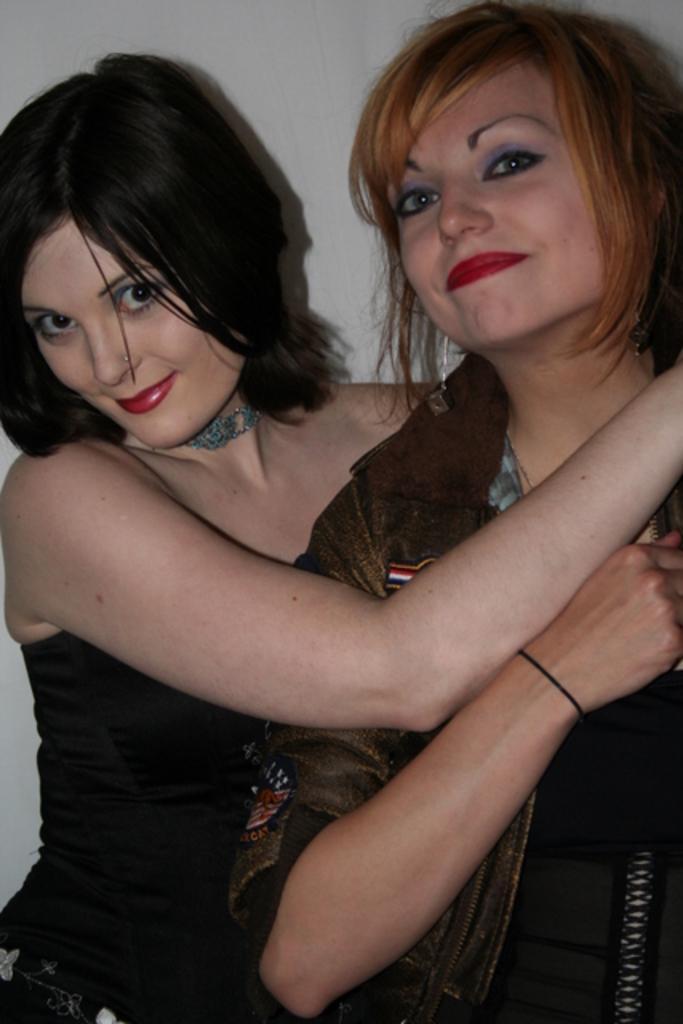Can you describe this image briefly? In this image there are two women standing, in the background of the image there is a wall. 